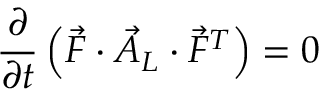<formula> <loc_0><loc_0><loc_500><loc_500>\frac { \partial } { \partial t } \left ( \vec { F } \cdot \vec { A } _ { L } \cdot \vec { F } ^ { T } \right ) = 0</formula> 